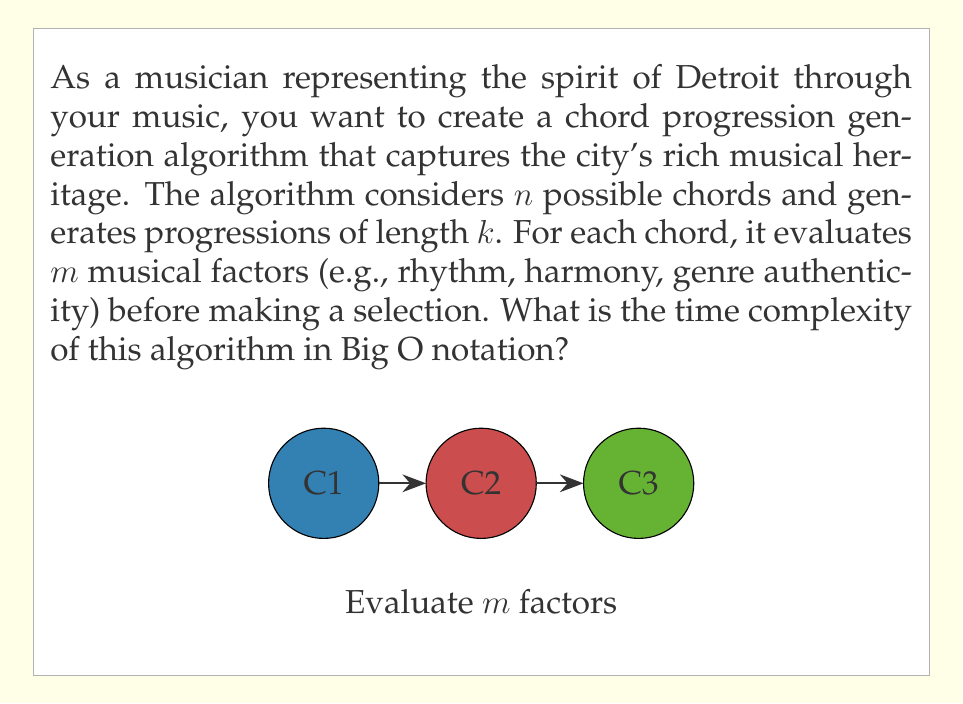Can you solve this math problem? Let's break down the algorithm and analyze its complexity step by step:

1) The algorithm generates a chord progression of length $k$. This means we need to select $k$ chords in total.

2) For each of these $k$ positions in the progression:
   a) We consider all $n$ possible chords.
   b) For each of these $n$ chords, we evaluate $m$ musical factors.

3) The evaluation of $m$ factors for a single chord takes $O(m)$ time.

4) For each position in the progression, we perform this evaluation $n$ times (once for each possible chord). This gives us $O(n \cdot m)$ operations for each position.

5) We repeat this process for all $k$ positions in the progression.

6) Therefore, the total number of operations is:

   $$ O(k \cdot n \cdot m) $$

This represents the time complexity of the algorithm.

Note: This analysis assumes that the selection of the best chord after evaluating all factors takes constant time, which is reasonable if we're keeping track of the best option as we go.
Answer: $O(knm)$ 